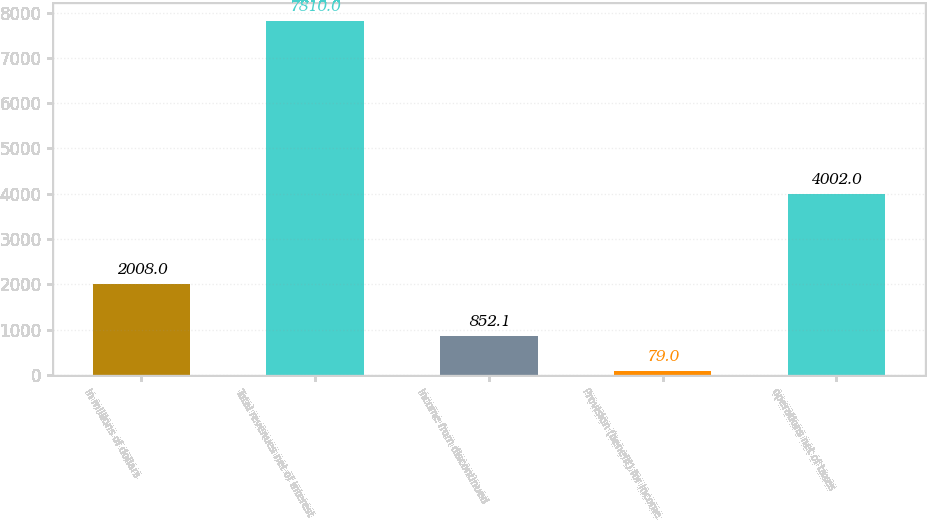Convert chart to OTSL. <chart><loc_0><loc_0><loc_500><loc_500><bar_chart><fcel>In millions of dollars<fcel>Total revenues net of interest<fcel>Income from discontinued<fcel>Provision (benefit) for income<fcel>operations net of taxes<nl><fcel>2008<fcel>7810<fcel>852.1<fcel>79<fcel>4002<nl></chart> 